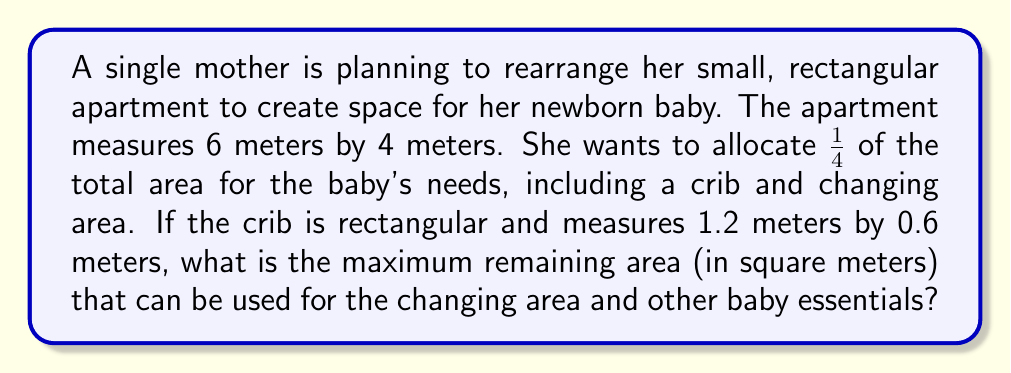Solve this math problem. Let's approach this step-by-step:

1. Calculate the total area of the apartment:
   $$ A_{total} = 6m \times 4m = 24m^2 $$

2. Determine the area to be allocated for the baby's needs (1/4 of the total):
   $$ A_{baby} = \frac{1}{4} \times 24m^2 = 6m^2 $$

3. Calculate the area occupied by the crib:
   $$ A_{crib} = 1.2m \times 0.6m = 0.72m^2 $$

4. Find the remaining area for the changing area and other baby essentials:
   $$ A_{remaining} = A_{baby} - A_{crib} $$
   $$ A_{remaining} = 6m^2 - 0.72m^2 = 5.28m^2 $$

Therefore, the maximum remaining area that can be used for the changing area and other baby essentials is 5.28 square meters.
Answer: $5.28m^2$ 